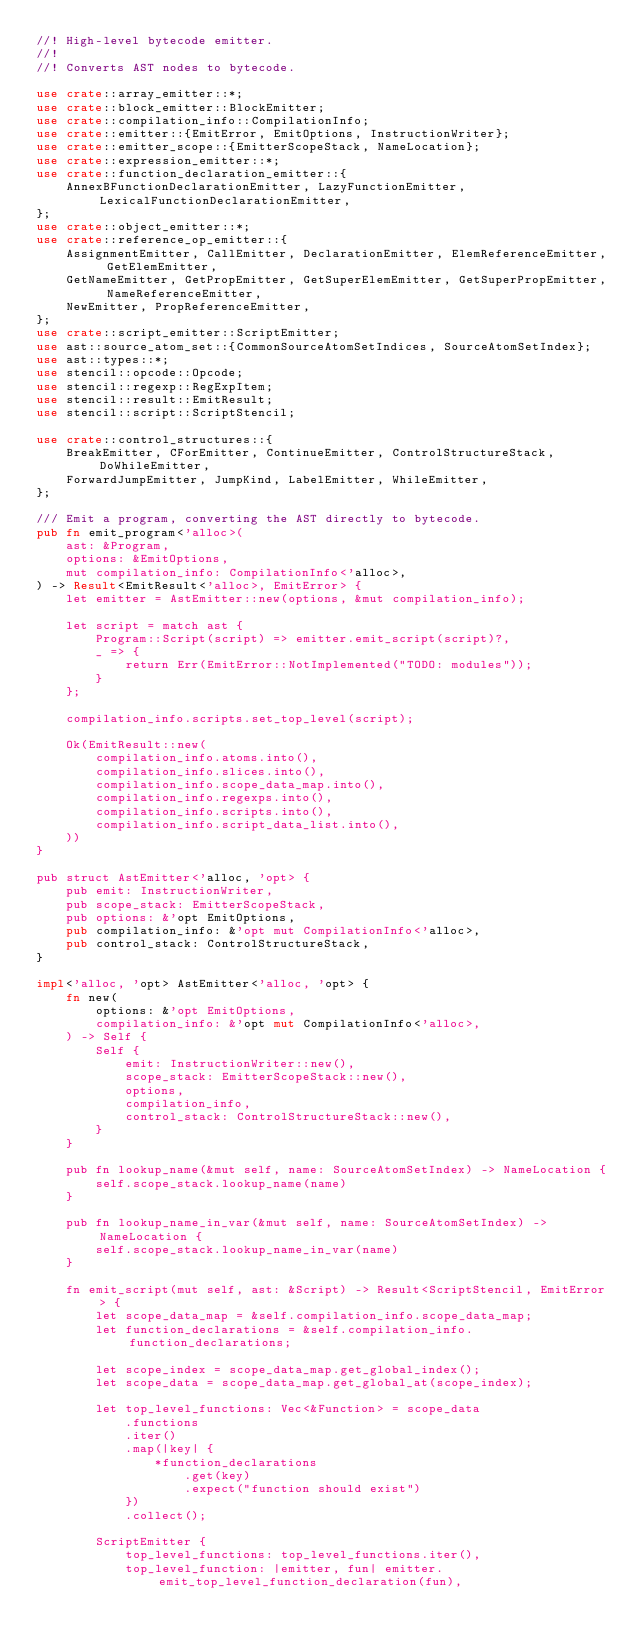<code> <loc_0><loc_0><loc_500><loc_500><_Rust_>//! High-level bytecode emitter.
//!
//! Converts AST nodes to bytecode.

use crate::array_emitter::*;
use crate::block_emitter::BlockEmitter;
use crate::compilation_info::CompilationInfo;
use crate::emitter::{EmitError, EmitOptions, InstructionWriter};
use crate::emitter_scope::{EmitterScopeStack, NameLocation};
use crate::expression_emitter::*;
use crate::function_declaration_emitter::{
    AnnexBFunctionDeclarationEmitter, LazyFunctionEmitter, LexicalFunctionDeclarationEmitter,
};
use crate::object_emitter::*;
use crate::reference_op_emitter::{
    AssignmentEmitter, CallEmitter, DeclarationEmitter, ElemReferenceEmitter, GetElemEmitter,
    GetNameEmitter, GetPropEmitter, GetSuperElemEmitter, GetSuperPropEmitter, NameReferenceEmitter,
    NewEmitter, PropReferenceEmitter,
};
use crate::script_emitter::ScriptEmitter;
use ast::source_atom_set::{CommonSourceAtomSetIndices, SourceAtomSetIndex};
use ast::types::*;
use stencil::opcode::Opcode;
use stencil::regexp::RegExpItem;
use stencil::result::EmitResult;
use stencil::script::ScriptStencil;

use crate::control_structures::{
    BreakEmitter, CForEmitter, ContinueEmitter, ControlStructureStack, DoWhileEmitter,
    ForwardJumpEmitter, JumpKind, LabelEmitter, WhileEmitter,
};

/// Emit a program, converting the AST directly to bytecode.
pub fn emit_program<'alloc>(
    ast: &Program,
    options: &EmitOptions,
    mut compilation_info: CompilationInfo<'alloc>,
) -> Result<EmitResult<'alloc>, EmitError> {
    let emitter = AstEmitter::new(options, &mut compilation_info);

    let script = match ast {
        Program::Script(script) => emitter.emit_script(script)?,
        _ => {
            return Err(EmitError::NotImplemented("TODO: modules"));
        }
    };

    compilation_info.scripts.set_top_level(script);

    Ok(EmitResult::new(
        compilation_info.atoms.into(),
        compilation_info.slices.into(),
        compilation_info.scope_data_map.into(),
        compilation_info.regexps.into(),
        compilation_info.scripts.into(),
        compilation_info.script_data_list.into(),
    ))
}

pub struct AstEmitter<'alloc, 'opt> {
    pub emit: InstructionWriter,
    pub scope_stack: EmitterScopeStack,
    pub options: &'opt EmitOptions,
    pub compilation_info: &'opt mut CompilationInfo<'alloc>,
    pub control_stack: ControlStructureStack,
}

impl<'alloc, 'opt> AstEmitter<'alloc, 'opt> {
    fn new(
        options: &'opt EmitOptions,
        compilation_info: &'opt mut CompilationInfo<'alloc>,
    ) -> Self {
        Self {
            emit: InstructionWriter::new(),
            scope_stack: EmitterScopeStack::new(),
            options,
            compilation_info,
            control_stack: ControlStructureStack::new(),
        }
    }

    pub fn lookup_name(&mut self, name: SourceAtomSetIndex) -> NameLocation {
        self.scope_stack.lookup_name(name)
    }

    pub fn lookup_name_in_var(&mut self, name: SourceAtomSetIndex) -> NameLocation {
        self.scope_stack.lookup_name_in_var(name)
    }

    fn emit_script(mut self, ast: &Script) -> Result<ScriptStencil, EmitError> {
        let scope_data_map = &self.compilation_info.scope_data_map;
        let function_declarations = &self.compilation_info.function_declarations;

        let scope_index = scope_data_map.get_global_index();
        let scope_data = scope_data_map.get_global_at(scope_index);

        let top_level_functions: Vec<&Function> = scope_data
            .functions
            .iter()
            .map(|key| {
                *function_declarations
                    .get(key)
                    .expect("function should exist")
            })
            .collect();

        ScriptEmitter {
            top_level_functions: top_level_functions.iter(),
            top_level_function: |emitter, fun| emitter.emit_top_level_function_declaration(fun),</code> 